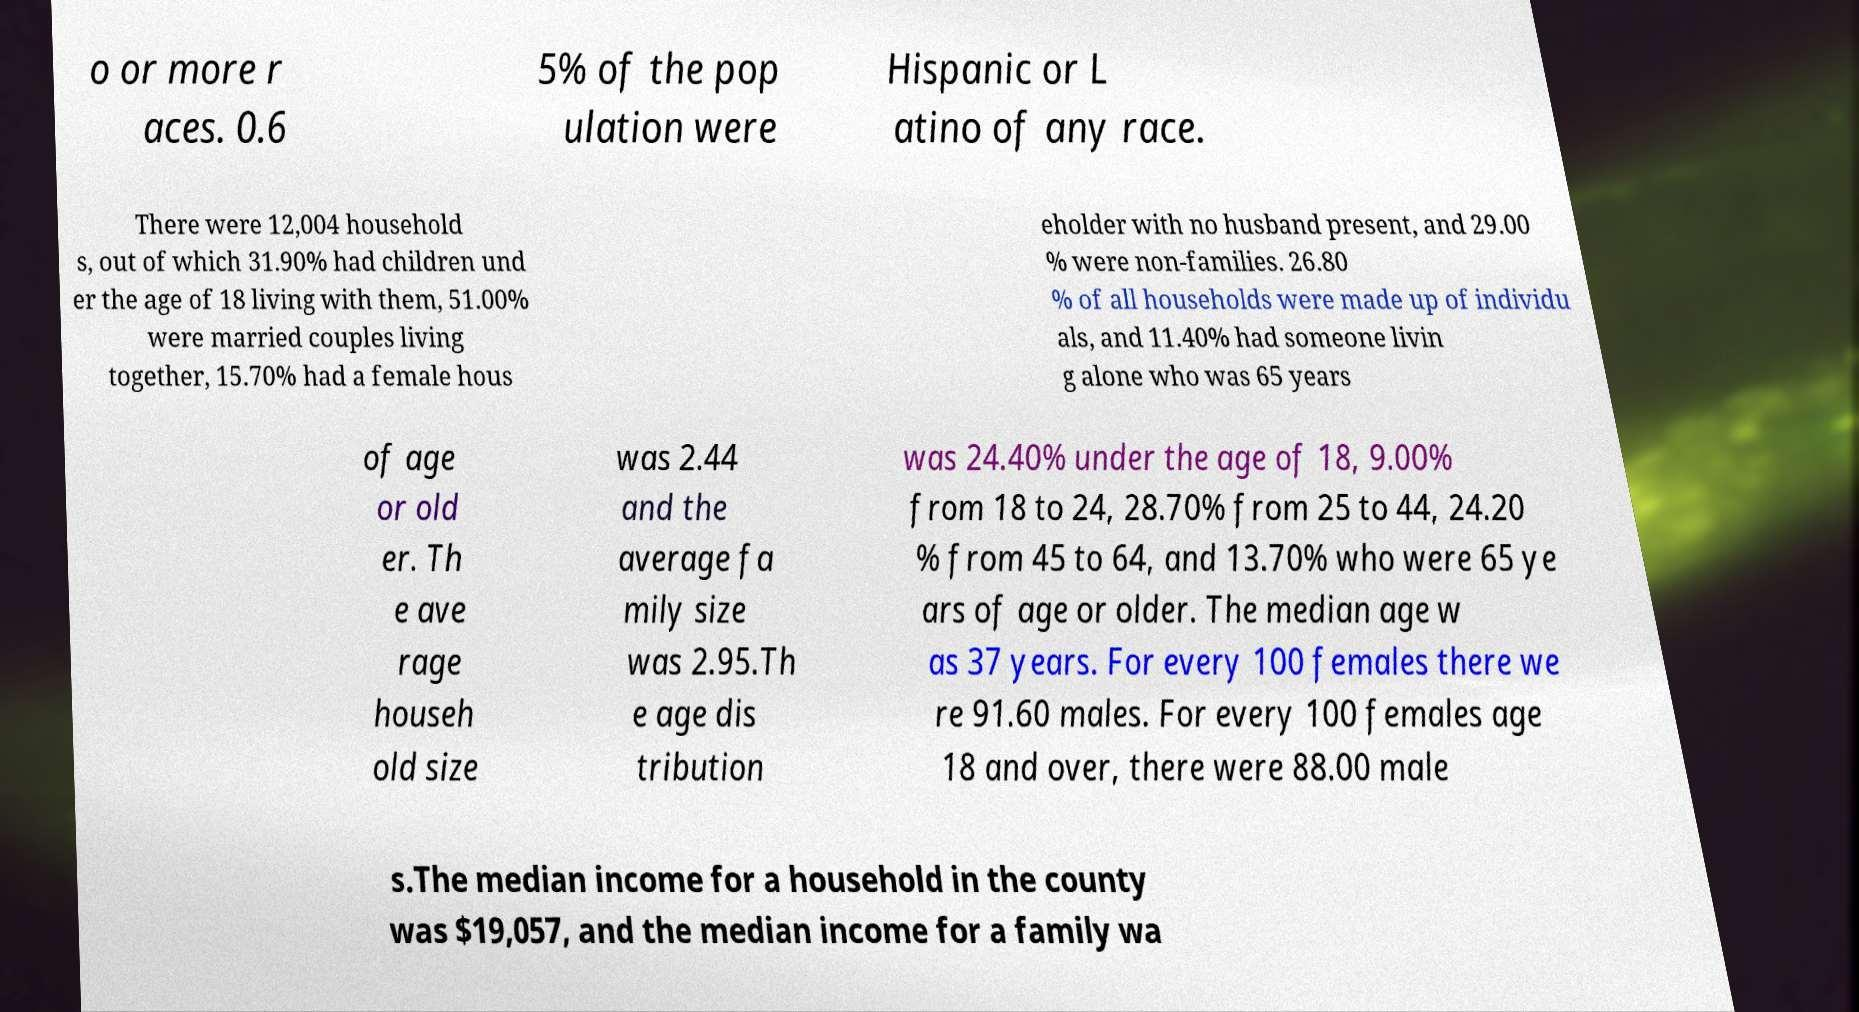Can you read and provide the text displayed in the image?This photo seems to have some interesting text. Can you extract and type it out for me? o or more r aces. 0.6 5% of the pop ulation were Hispanic or L atino of any race. There were 12,004 household s, out of which 31.90% had children und er the age of 18 living with them, 51.00% were married couples living together, 15.70% had a female hous eholder with no husband present, and 29.00 % were non-families. 26.80 % of all households were made up of individu als, and 11.40% had someone livin g alone who was 65 years of age or old er. Th e ave rage househ old size was 2.44 and the average fa mily size was 2.95.Th e age dis tribution was 24.40% under the age of 18, 9.00% from 18 to 24, 28.70% from 25 to 44, 24.20 % from 45 to 64, and 13.70% who were 65 ye ars of age or older. The median age w as 37 years. For every 100 females there we re 91.60 males. For every 100 females age 18 and over, there were 88.00 male s.The median income for a household in the county was $19,057, and the median income for a family wa 